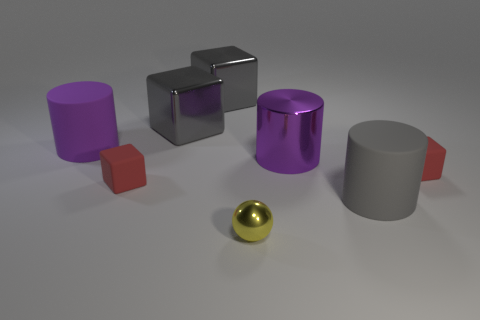Subtract 1 cubes. How many cubes are left? 3 Add 1 big things. How many objects exist? 9 Subtract all balls. How many objects are left? 7 Subtract all large gray shiny blocks. Subtract all large purple metallic cylinders. How many objects are left? 5 Add 3 yellow shiny spheres. How many yellow shiny spheres are left? 4 Add 3 big purple cylinders. How many big purple cylinders exist? 5 Subtract 0 purple balls. How many objects are left? 8 